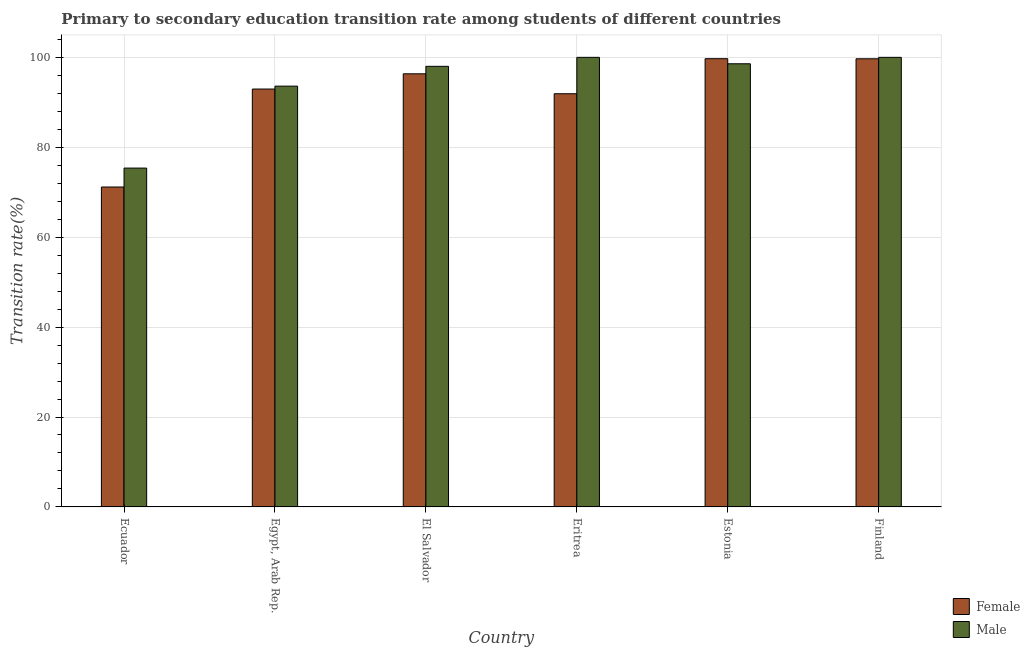How many different coloured bars are there?
Offer a very short reply. 2. How many groups of bars are there?
Make the answer very short. 6. Are the number of bars on each tick of the X-axis equal?
Provide a short and direct response. Yes. How many bars are there on the 1st tick from the left?
Provide a succinct answer. 2. How many bars are there on the 5th tick from the right?
Offer a terse response. 2. What is the label of the 2nd group of bars from the left?
Your answer should be very brief. Egypt, Arab Rep. In how many cases, is the number of bars for a given country not equal to the number of legend labels?
Give a very brief answer. 0. What is the transition rate among female students in El Salvador?
Your response must be concise. 96.34. Across all countries, what is the maximum transition rate among female students?
Your answer should be compact. 99.7. Across all countries, what is the minimum transition rate among male students?
Your answer should be compact. 75.37. In which country was the transition rate among female students maximum?
Provide a succinct answer. Estonia. In which country was the transition rate among female students minimum?
Your answer should be very brief. Ecuador. What is the total transition rate among male students in the graph?
Ensure brevity in your answer.  565.54. What is the difference between the transition rate among male students in Ecuador and that in Estonia?
Offer a terse response. -23.2. What is the difference between the transition rate among female students in El Salvador and the transition rate among male students in Eritrea?
Provide a short and direct response. -3.66. What is the average transition rate among male students per country?
Your answer should be very brief. 94.26. What is the difference between the transition rate among male students and transition rate among female students in Finland?
Offer a terse response. 0.32. What is the ratio of the transition rate among male students in El Salvador to that in Eritrea?
Provide a succinct answer. 0.98. Is the transition rate among male students in Eritrea less than that in Finland?
Keep it short and to the point. No. What is the difference between the highest and the lowest transition rate among female students?
Provide a succinct answer. 28.54. In how many countries, is the transition rate among male students greater than the average transition rate among male students taken over all countries?
Your answer should be very brief. 4. Is the sum of the transition rate among female students in Egypt, Arab Rep. and Eritrea greater than the maximum transition rate among male students across all countries?
Ensure brevity in your answer.  Yes. What does the 1st bar from the left in El Salvador represents?
Your answer should be very brief. Female. What does the 2nd bar from the right in Eritrea represents?
Your response must be concise. Female. How many bars are there?
Your answer should be very brief. 12. How many countries are there in the graph?
Ensure brevity in your answer.  6. What is the difference between two consecutive major ticks on the Y-axis?
Ensure brevity in your answer.  20. Are the values on the major ticks of Y-axis written in scientific E-notation?
Provide a short and direct response. No. Does the graph contain any zero values?
Keep it short and to the point. No. Does the graph contain grids?
Your response must be concise. Yes. Where does the legend appear in the graph?
Your response must be concise. Bottom right. How are the legend labels stacked?
Keep it short and to the point. Vertical. What is the title of the graph?
Ensure brevity in your answer.  Primary to secondary education transition rate among students of different countries. Does "Electricity and heat production" appear as one of the legend labels in the graph?
Provide a short and direct response. No. What is the label or title of the Y-axis?
Offer a terse response. Transition rate(%). What is the Transition rate(%) in Female in Ecuador?
Your answer should be very brief. 71.16. What is the Transition rate(%) in Male in Ecuador?
Provide a short and direct response. 75.37. What is the Transition rate(%) of Female in Egypt, Arab Rep.?
Make the answer very short. 92.95. What is the Transition rate(%) in Male in Egypt, Arab Rep.?
Your answer should be very brief. 93.6. What is the Transition rate(%) of Female in El Salvador?
Give a very brief answer. 96.34. What is the Transition rate(%) of Male in El Salvador?
Your answer should be compact. 98. What is the Transition rate(%) of Female in Eritrea?
Ensure brevity in your answer.  91.91. What is the Transition rate(%) of Female in Estonia?
Provide a short and direct response. 99.7. What is the Transition rate(%) of Male in Estonia?
Your answer should be very brief. 98.57. What is the Transition rate(%) of Female in Finland?
Ensure brevity in your answer.  99.68. What is the Transition rate(%) in Male in Finland?
Provide a succinct answer. 100. Across all countries, what is the maximum Transition rate(%) in Female?
Offer a terse response. 99.7. Across all countries, what is the minimum Transition rate(%) in Female?
Your answer should be compact. 71.16. Across all countries, what is the minimum Transition rate(%) in Male?
Your answer should be compact. 75.37. What is the total Transition rate(%) in Female in the graph?
Your answer should be very brief. 551.74. What is the total Transition rate(%) of Male in the graph?
Make the answer very short. 565.54. What is the difference between the Transition rate(%) of Female in Ecuador and that in Egypt, Arab Rep.?
Give a very brief answer. -21.79. What is the difference between the Transition rate(%) in Male in Ecuador and that in Egypt, Arab Rep.?
Provide a short and direct response. -18.23. What is the difference between the Transition rate(%) of Female in Ecuador and that in El Salvador?
Ensure brevity in your answer.  -25.18. What is the difference between the Transition rate(%) in Male in Ecuador and that in El Salvador?
Your answer should be compact. -22.63. What is the difference between the Transition rate(%) in Female in Ecuador and that in Eritrea?
Ensure brevity in your answer.  -20.74. What is the difference between the Transition rate(%) of Male in Ecuador and that in Eritrea?
Give a very brief answer. -24.63. What is the difference between the Transition rate(%) in Female in Ecuador and that in Estonia?
Offer a very short reply. -28.54. What is the difference between the Transition rate(%) of Male in Ecuador and that in Estonia?
Your response must be concise. -23.2. What is the difference between the Transition rate(%) of Female in Ecuador and that in Finland?
Provide a succinct answer. -28.52. What is the difference between the Transition rate(%) in Male in Ecuador and that in Finland?
Ensure brevity in your answer.  -24.63. What is the difference between the Transition rate(%) in Female in Egypt, Arab Rep. and that in El Salvador?
Provide a short and direct response. -3.39. What is the difference between the Transition rate(%) in Male in Egypt, Arab Rep. and that in El Salvador?
Your response must be concise. -4.4. What is the difference between the Transition rate(%) of Female in Egypt, Arab Rep. and that in Eritrea?
Offer a very short reply. 1.05. What is the difference between the Transition rate(%) of Male in Egypt, Arab Rep. and that in Eritrea?
Offer a very short reply. -6.4. What is the difference between the Transition rate(%) of Female in Egypt, Arab Rep. and that in Estonia?
Provide a succinct answer. -6.75. What is the difference between the Transition rate(%) of Male in Egypt, Arab Rep. and that in Estonia?
Offer a terse response. -4.97. What is the difference between the Transition rate(%) of Female in Egypt, Arab Rep. and that in Finland?
Your answer should be very brief. -6.73. What is the difference between the Transition rate(%) of Male in Egypt, Arab Rep. and that in Finland?
Offer a very short reply. -6.4. What is the difference between the Transition rate(%) of Female in El Salvador and that in Eritrea?
Ensure brevity in your answer.  4.43. What is the difference between the Transition rate(%) in Male in El Salvador and that in Eritrea?
Ensure brevity in your answer.  -2. What is the difference between the Transition rate(%) in Female in El Salvador and that in Estonia?
Your answer should be very brief. -3.36. What is the difference between the Transition rate(%) of Male in El Salvador and that in Estonia?
Your response must be concise. -0.57. What is the difference between the Transition rate(%) in Female in El Salvador and that in Finland?
Keep it short and to the point. -3.34. What is the difference between the Transition rate(%) of Male in El Salvador and that in Finland?
Offer a very short reply. -2. What is the difference between the Transition rate(%) of Female in Eritrea and that in Estonia?
Ensure brevity in your answer.  -7.8. What is the difference between the Transition rate(%) in Male in Eritrea and that in Estonia?
Offer a terse response. 1.43. What is the difference between the Transition rate(%) in Female in Eritrea and that in Finland?
Your response must be concise. -7.77. What is the difference between the Transition rate(%) of Female in Estonia and that in Finland?
Your answer should be compact. 0.02. What is the difference between the Transition rate(%) of Male in Estonia and that in Finland?
Give a very brief answer. -1.43. What is the difference between the Transition rate(%) of Female in Ecuador and the Transition rate(%) of Male in Egypt, Arab Rep.?
Provide a short and direct response. -22.44. What is the difference between the Transition rate(%) in Female in Ecuador and the Transition rate(%) in Male in El Salvador?
Keep it short and to the point. -26.84. What is the difference between the Transition rate(%) of Female in Ecuador and the Transition rate(%) of Male in Eritrea?
Give a very brief answer. -28.84. What is the difference between the Transition rate(%) of Female in Ecuador and the Transition rate(%) of Male in Estonia?
Offer a very short reply. -27.41. What is the difference between the Transition rate(%) of Female in Ecuador and the Transition rate(%) of Male in Finland?
Your response must be concise. -28.84. What is the difference between the Transition rate(%) in Female in Egypt, Arab Rep. and the Transition rate(%) in Male in El Salvador?
Your answer should be compact. -5.05. What is the difference between the Transition rate(%) of Female in Egypt, Arab Rep. and the Transition rate(%) of Male in Eritrea?
Your answer should be very brief. -7.05. What is the difference between the Transition rate(%) of Female in Egypt, Arab Rep. and the Transition rate(%) of Male in Estonia?
Your answer should be compact. -5.62. What is the difference between the Transition rate(%) in Female in Egypt, Arab Rep. and the Transition rate(%) in Male in Finland?
Provide a succinct answer. -7.05. What is the difference between the Transition rate(%) of Female in El Salvador and the Transition rate(%) of Male in Eritrea?
Ensure brevity in your answer.  -3.66. What is the difference between the Transition rate(%) in Female in El Salvador and the Transition rate(%) in Male in Estonia?
Provide a short and direct response. -2.23. What is the difference between the Transition rate(%) in Female in El Salvador and the Transition rate(%) in Male in Finland?
Offer a very short reply. -3.66. What is the difference between the Transition rate(%) in Female in Eritrea and the Transition rate(%) in Male in Estonia?
Give a very brief answer. -6.67. What is the difference between the Transition rate(%) of Female in Eritrea and the Transition rate(%) of Male in Finland?
Offer a very short reply. -8.09. What is the difference between the Transition rate(%) in Female in Estonia and the Transition rate(%) in Male in Finland?
Ensure brevity in your answer.  -0.3. What is the average Transition rate(%) of Female per country?
Make the answer very short. 91.96. What is the average Transition rate(%) of Male per country?
Keep it short and to the point. 94.26. What is the difference between the Transition rate(%) of Female and Transition rate(%) of Male in Ecuador?
Your response must be concise. -4.21. What is the difference between the Transition rate(%) of Female and Transition rate(%) of Male in Egypt, Arab Rep.?
Offer a terse response. -0.65. What is the difference between the Transition rate(%) of Female and Transition rate(%) of Male in El Salvador?
Give a very brief answer. -1.66. What is the difference between the Transition rate(%) of Female and Transition rate(%) of Male in Eritrea?
Your answer should be very brief. -8.09. What is the difference between the Transition rate(%) of Female and Transition rate(%) of Male in Estonia?
Offer a terse response. 1.13. What is the difference between the Transition rate(%) of Female and Transition rate(%) of Male in Finland?
Provide a succinct answer. -0.32. What is the ratio of the Transition rate(%) in Female in Ecuador to that in Egypt, Arab Rep.?
Keep it short and to the point. 0.77. What is the ratio of the Transition rate(%) in Male in Ecuador to that in Egypt, Arab Rep.?
Your response must be concise. 0.81. What is the ratio of the Transition rate(%) of Female in Ecuador to that in El Salvador?
Offer a very short reply. 0.74. What is the ratio of the Transition rate(%) in Male in Ecuador to that in El Salvador?
Offer a very short reply. 0.77. What is the ratio of the Transition rate(%) of Female in Ecuador to that in Eritrea?
Provide a succinct answer. 0.77. What is the ratio of the Transition rate(%) of Male in Ecuador to that in Eritrea?
Give a very brief answer. 0.75. What is the ratio of the Transition rate(%) in Female in Ecuador to that in Estonia?
Your answer should be very brief. 0.71. What is the ratio of the Transition rate(%) in Male in Ecuador to that in Estonia?
Provide a succinct answer. 0.76. What is the ratio of the Transition rate(%) in Female in Ecuador to that in Finland?
Your answer should be compact. 0.71. What is the ratio of the Transition rate(%) in Male in Ecuador to that in Finland?
Provide a succinct answer. 0.75. What is the ratio of the Transition rate(%) in Female in Egypt, Arab Rep. to that in El Salvador?
Provide a short and direct response. 0.96. What is the ratio of the Transition rate(%) of Male in Egypt, Arab Rep. to that in El Salvador?
Give a very brief answer. 0.96. What is the ratio of the Transition rate(%) in Female in Egypt, Arab Rep. to that in Eritrea?
Your response must be concise. 1.01. What is the ratio of the Transition rate(%) of Male in Egypt, Arab Rep. to that in Eritrea?
Make the answer very short. 0.94. What is the ratio of the Transition rate(%) of Female in Egypt, Arab Rep. to that in Estonia?
Your answer should be compact. 0.93. What is the ratio of the Transition rate(%) of Male in Egypt, Arab Rep. to that in Estonia?
Provide a short and direct response. 0.95. What is the ratio of the Transition rate(%) of Female in Egypt, Arab Rep. to that in Finland?
Offer a terse response. 0.93. What is the ratio of the Transition rate(%) in Male in Egypt, Arab Rep. to that in Finland?
Ensure brevity in your answer.  0.94. What is the ratio of the Transition rate(%) of Female in El Salvador to that in Eritrea?
Your response must be concise. 1.05. What is the ratio of the Transition rate(%) of Male in El Salvador to that in Eritrea?
Your answer should be compact. 0.98. What is the ratio of the Transition rate(%) of Female in El Salvador to that in Estonia?
Your answer should be very brief. 0.97. What is the ratio of the Transition rate(%) of Female in El Salvador to that in Finland?
Your answer should be very brief. 0.97. What is the ratio of the Transition rate(%) in Female in Eritrea to that in Estonia?
Ensure brevity in your answer.  0.92. What is the ratio of the Transition rate(%) in Male in Eritrea to that in Estonia?
Offer a very short reply. 1.01. What is the ratio of the Transition rate(%) of Female in Eritrea to that in Finland?
Your answer should be very brief. 0.92. What is the ratio of the Transition rate(%) of Male in Estonia to that in Finland?
Keep it short and to the point. 0.99. What is the difference between the highest and the second highest Transition rate(%) of Female?
Give a very brief answer. 0.02. What is the difference between the highest and the second highest Transition rate(%) in Male?
Make the answer very short. 0. What is the difference between the highest and the lowest Transition rate(%) of Female?
Provide a succinct answer. 28.54. What is the difference between the highest and the lowest Transition rate(%) in Male?
Ensure brevity in your answer.  24.63. 